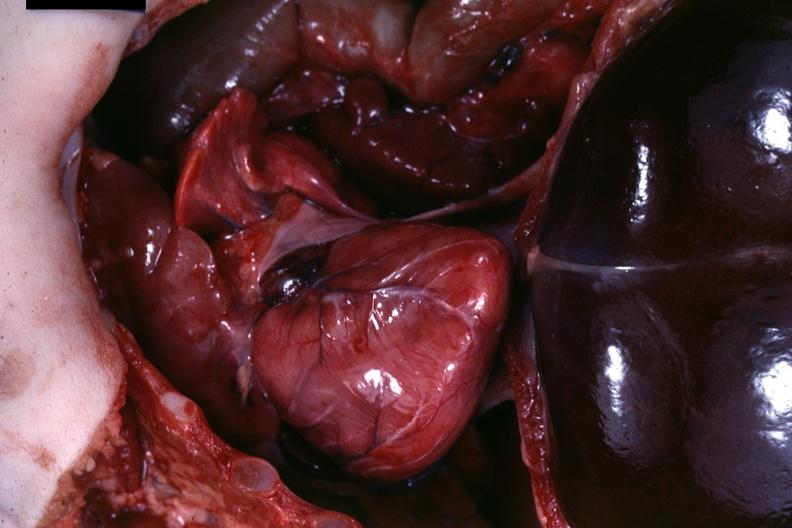what is present?
Answer the question using a single word or phrase. Soft tissue 